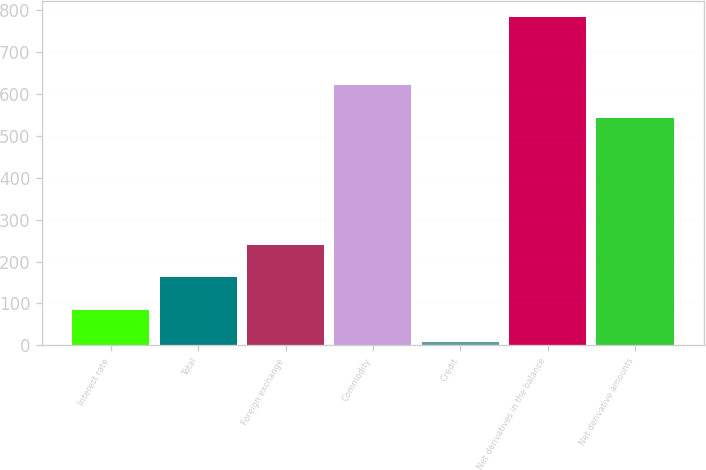Convert chart to OTSL. <chart><loc_0><loc_0><loc_500><loc_500><bar_chart><fcel>Interest rate<fcel>Total<fcel>Foreign exchange<fcel>Commodity<fcel>Credit<fcel>Net derivatives in the balance<fcel>Net derivative amounts<nl><fcel>84.7<fcel>162.4<fcel>240.1<fcel>620.7<fcel>7<fcel>784<fcel>543<nl></chart> 